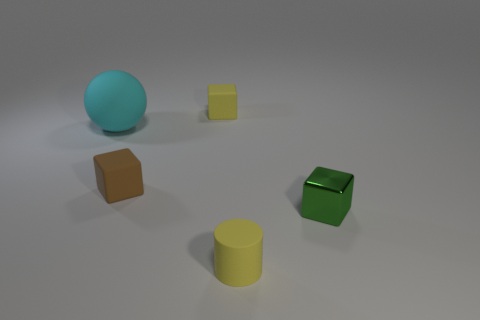Is there any other thing that is the same size as the cyan object?
Give a very brief answer. No. Is the number of tiny matte cylinders less than the number of objects?
Keep it short and to the point. Yes. There is a brown block that is on the left side of the small yellow matte block; what material is it?
Ensure brevity in your answer.  Rubber. There is a brown block that is the same size as the metallic object; what material is it?
Make the answer very short. Rubber. What is the tiny block behind the big thing that is to the left of the yellow object that is behind the cyan matte object made of?
Your response must be concise. Rubber. There is a yellow object that is behind the cyan matte object; is it the same size as the big cyan matte object?
Give a very brief answer. No. Are there more small brown matte blocks than gray metallic balls?
Ensure brevity in your answer.  Yes. What number of small things are blue shiny cylinders or cyan rubber things?
Provide a succinct answer. 0. What number of other objects are there of the same color as the big matte sphere?
Give a very brief answer. 0. How many other large balls are the same material as the large sphere?
Give a very brief answer. 0. 